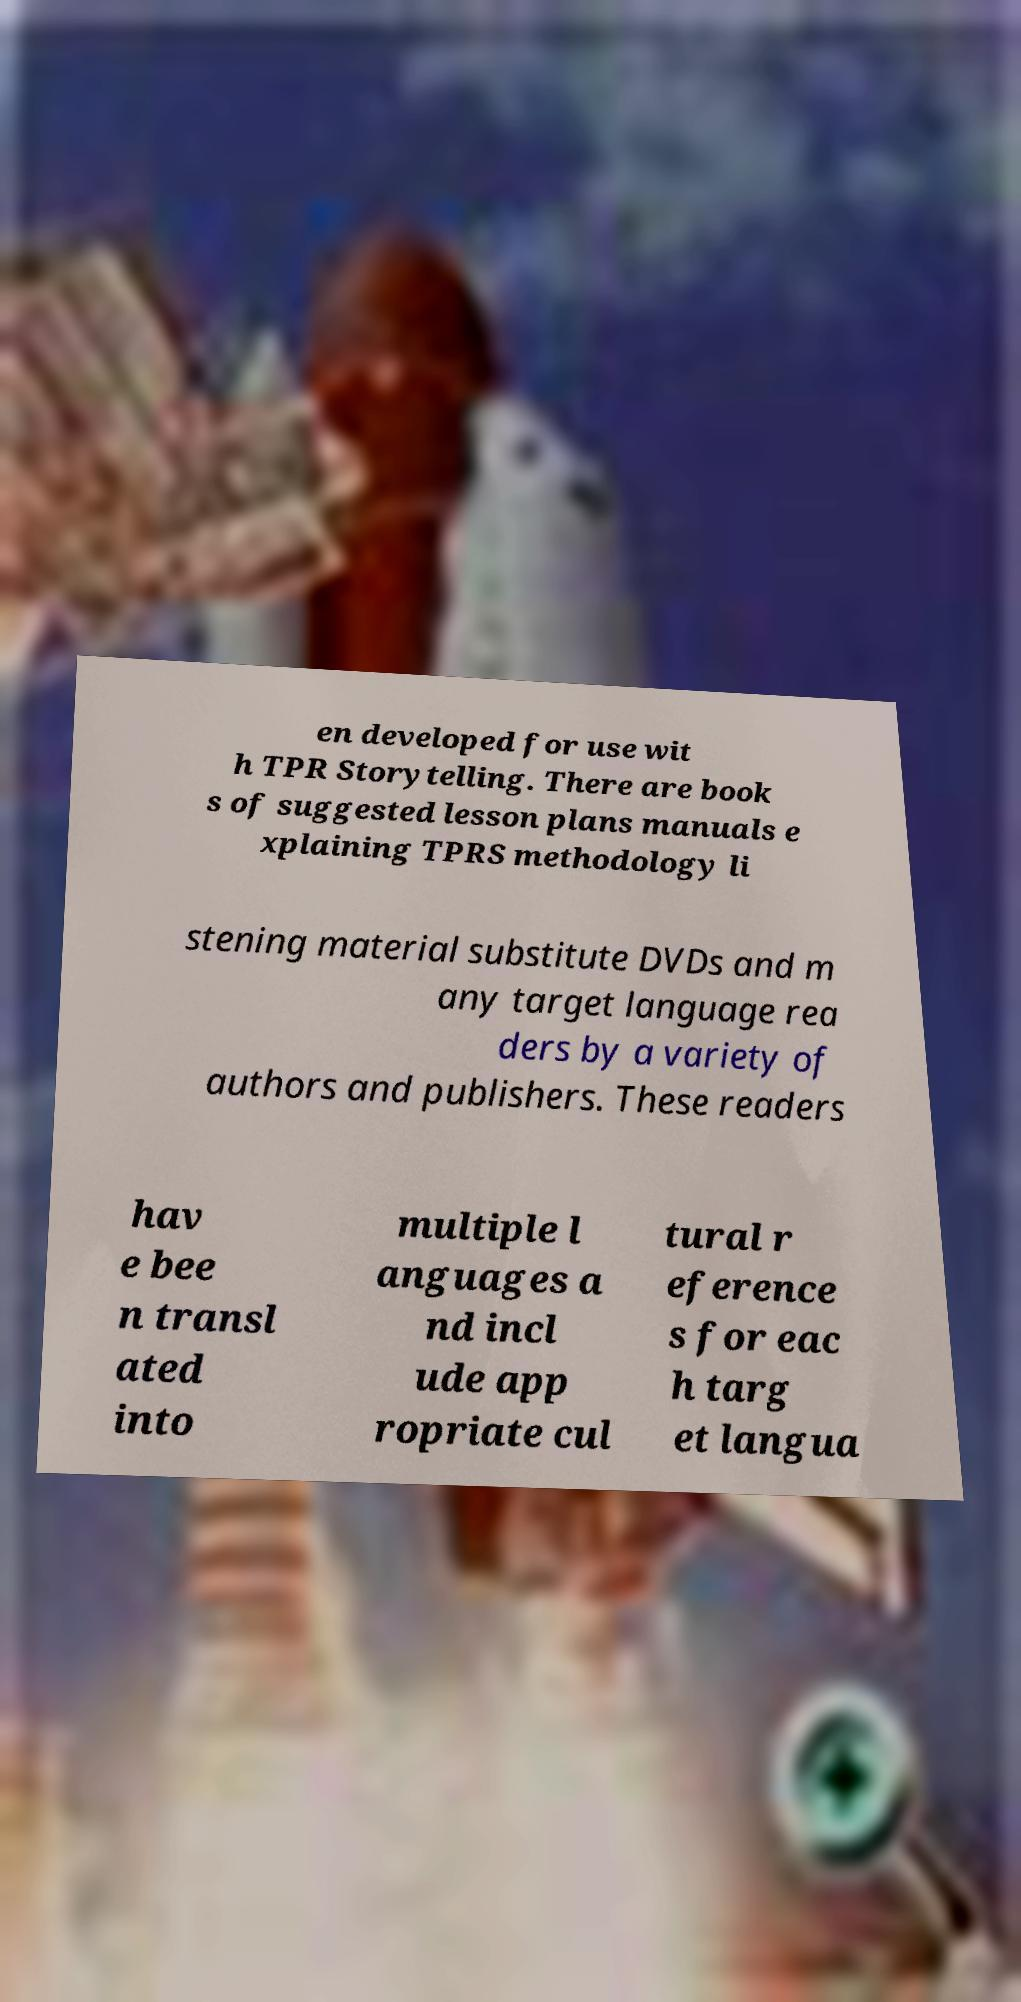Can you accurately transcribe the text from the provided image for me? en developed for use wit h TPR Storytelling. There are book s of suggested lesson plans manuals e xplaining TPRS methodology li stening material substitute DVDs and m any target language rea ders by a variety of authors and publishers. These readers hav e bee n transl ated into multiple l anguages a nd incl ude app ropriate cul tural r eference s for eac h targ et langua 